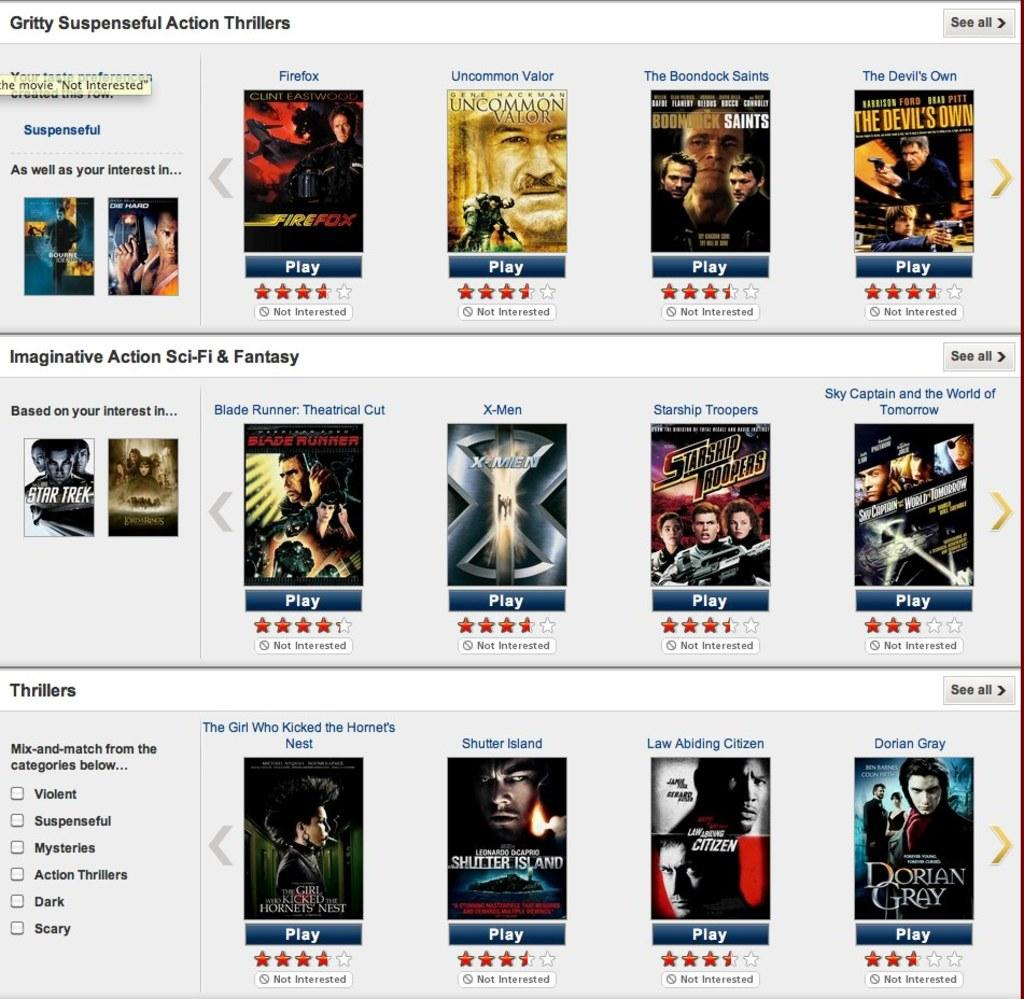<image>
Give a short and clear explanation of the subsequent image. A webpage of movies, the top genre is Gritty Suspense. 